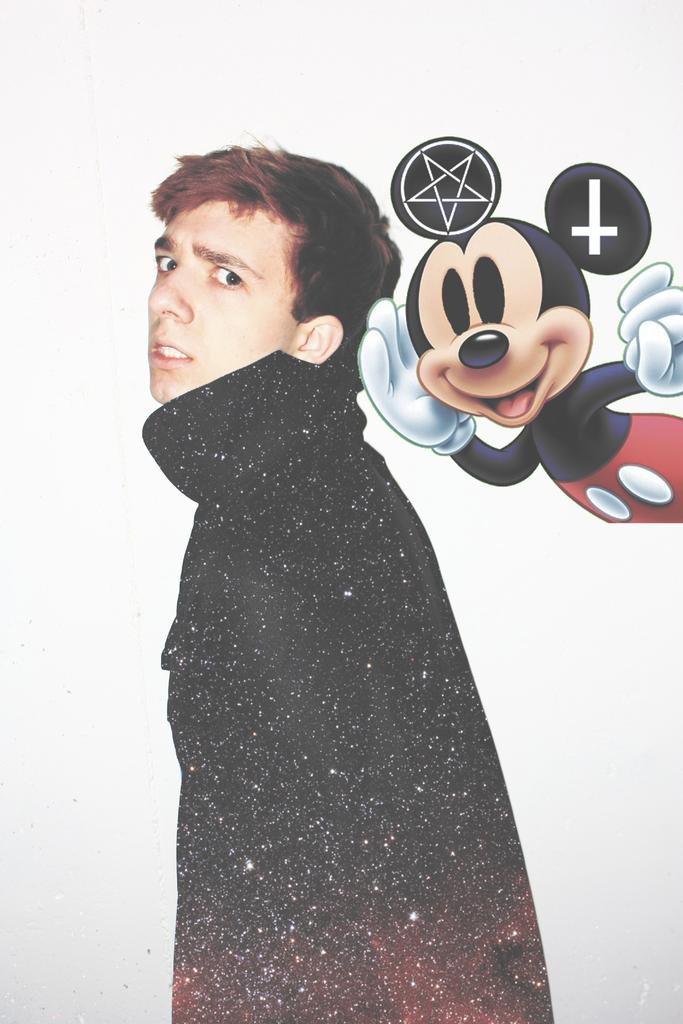Who or what is present in the image? There is a person in the image. What is the person wearing? The person is wearing a black jacket. What is the person doing in the image? The person is standing. What can be seen in the background of the image? There is a Mickey Mouse image in the background. How many locks are visible on the person's black jacket in the image? There is no mention of locks on the person's black jacket in the image. 